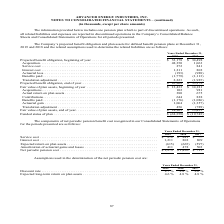According to Advanced Energy's financial document, What was service cost in 2019? According to the financial document, $272 (in thousands). The relevant text states: "34,498 Acquisition . 48,350 1,063 Service cost . 272 841 Interest cost . 1,211 802 Actuarial loss . (193) (988) Benefits paid . (1,779) (1,113) Translat..." Also, What was interest cost in 2018? According to the financial document, 802 (in thousands). The relevant text states: "vice cost . $ 272 $ 841 $ — Interest cost . 1,211 802 809 Expected return on plan assets . (615) (665) (597) Amortization of actuarial gains and losses ...." Also, What was the Expected return on plan assets in 2017? According to the financial document, (597) (in thousands). The relevant text states: "2 809 Expected return on plan assets . (615) (665) (597) Amortization of actuarial gains and losses . 411 478 503 Net periodic pension cost . $ 1,279 $ 1,456..." Also, can you calculate: What was the change in the net periodic pension cost between 2018 and 2019? Based on the calculation: $1,279-$1,456, the result is -177 (in thousands). This is based on the information: "osses . 411 478 503 Net periodic pension cost . $ 1,279 $ 1,456 $ 715 Assumptions used in the determination of the net periodic pension cost are: 411 478 503 Net periodic pension cost . $ 1,279 $ 1,45..." The key data points involved are: 1,279, 1,456. Also, can you calculate: What was the change in Amortization of actuarial gains and losses between 2017 and 2018? Based on the calculation: 478-503, the result is -25 (in thousands). This is based on the information: "Amortization of actuarial gains and losses . 411 478 503 Net periodic pension cost . $ 1,279 $ 1,456 $ 715 Assumptions used in the determination of the rtization of actuarial gains and losses . 411 47..." The key data points involved are: 478, 503. Also, can you calculate: What was the percentage change in Interest cost between 2018 and 2019? To answer this question, I need to perform calculations using the financial data. The calculation is: (1,211-802)/802, which equals 51 (percentage). This is based on the information: "Service cost . $ 272 $ 841 $ — Interest cost . 1,211 802 809 Expected return on plan assets . (615) (665) (597) Amortization of actuarial gains and loss vice cost . $ 272 $ 841 $ — Interest cost . 1,2..." The key data points involved are: 1,211, 802. 